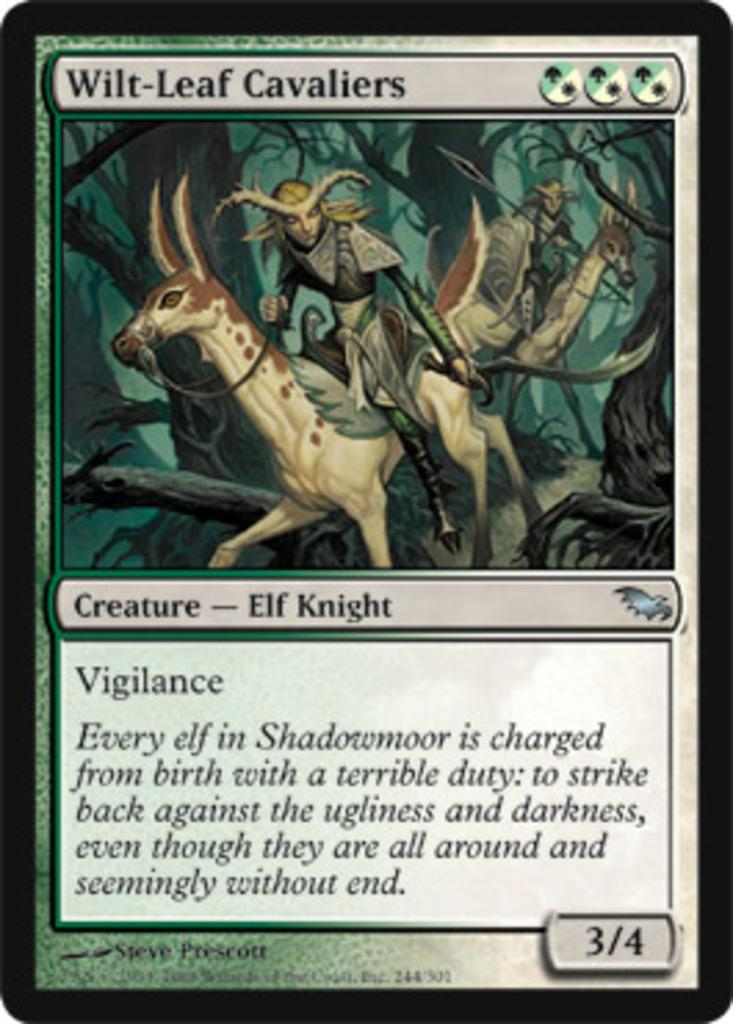What is happening in the main image? There is a cartoon of a man riding a horse in the image. What else can be seen at the bottom of the image? There is text written on a paper at the bottom of the image. What might be the source of this image? The image might be taken from a textbook. What type of eggnog is being served in the bedroom in the image? There is no eggnog or bedroom present in the image; it features a cartoon of a man riding a horse and text on a paper. What is the head of the man doing in the image? The image is a cartoon, and the man's head is not shown separately from his body. 